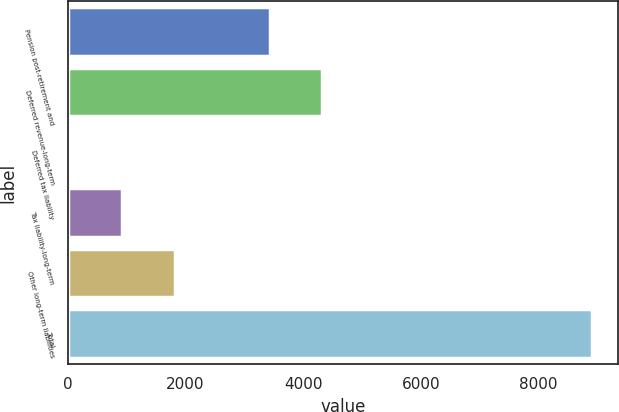Convert chart. <chart><loc_0><loc_0><loc_500><loc_500><bar_chart><fcel>Pension post-retirement and<fcel>Deferred revenue-long-term<fcel>Deferred tax liability<fcel>Tax liability-long-term<fcel>Other long-term liabilities<fcel>Total<nl><fcel>3432<fcel>4318.1<fcel>41<fcel>927.1<fcel>1813.2<fcel>8902<nl></chart> 